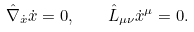Convert formula to latex. <formula><loc_0><loc_0><loc_500><loc_500>\hat { \nabla } _ { \dot { x } } \dot { x } = 0 , \quad \hat { L } _ { \mu \nu } \dot { x } ^ { \mu } = 0 .</formula> 